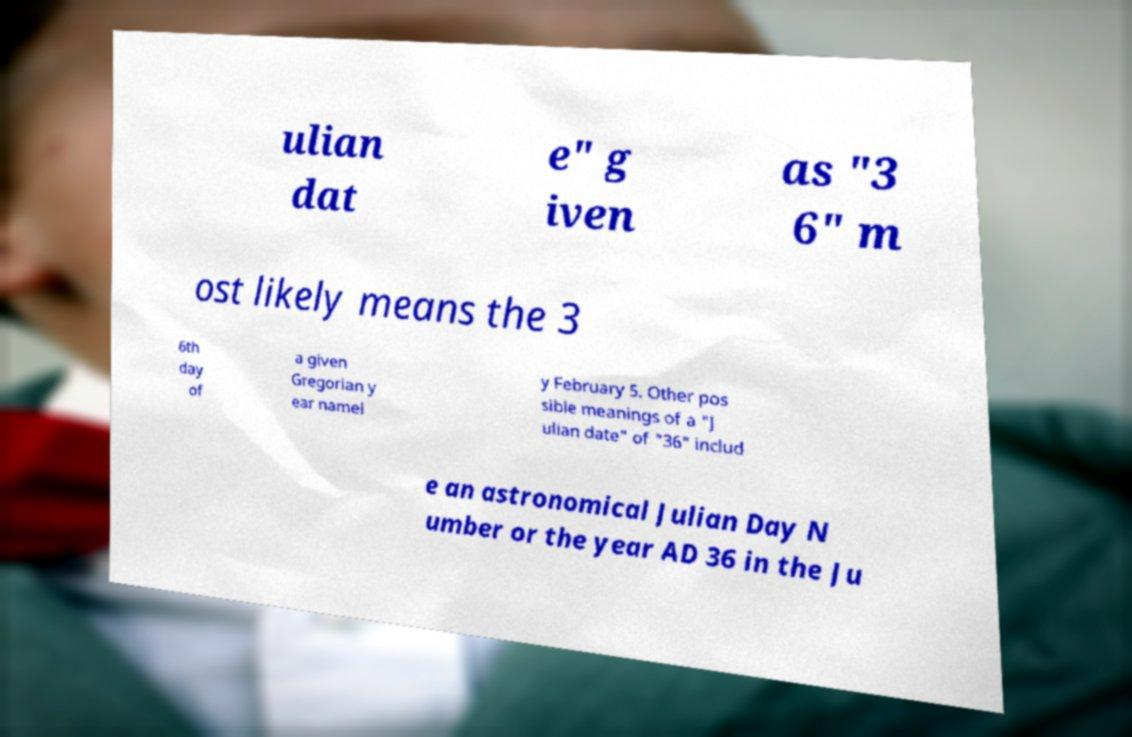Could you assist in decoding the text presented in this image and type it out clearly? ulian dat e" g iven as "3 6" m ost likely means the 3 6th day of a given Gregorian y ear namel y February 5. Other pos sible meanings of a "J ulian date" of "36" includ e an astronomical Julian Day N umber or the year AD 36 in the Ju 